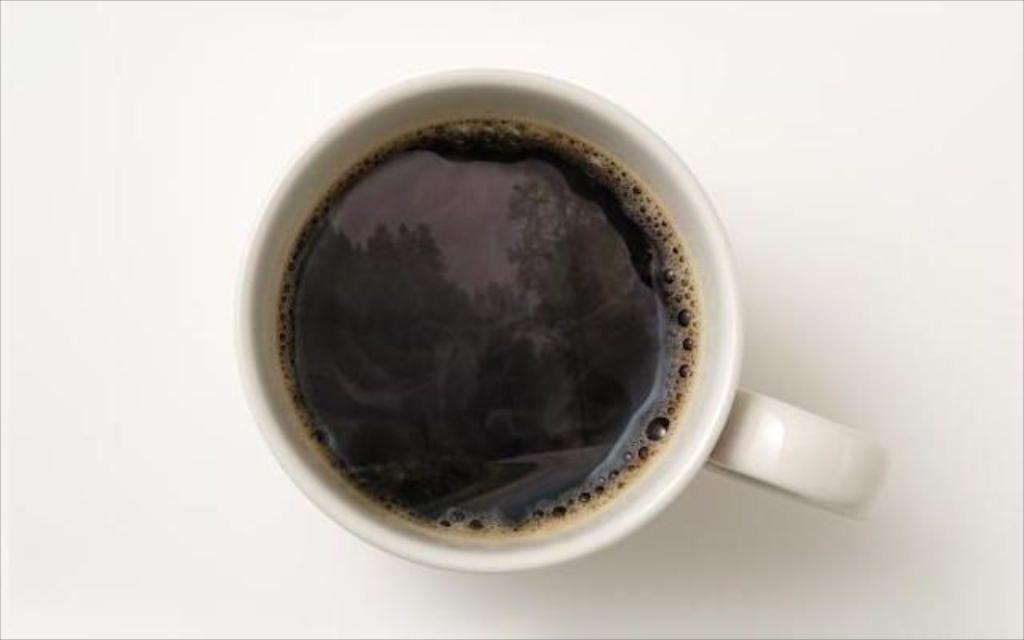Describe this image in one or two sentences. In the picture I can see a cup of coffee on the table. 